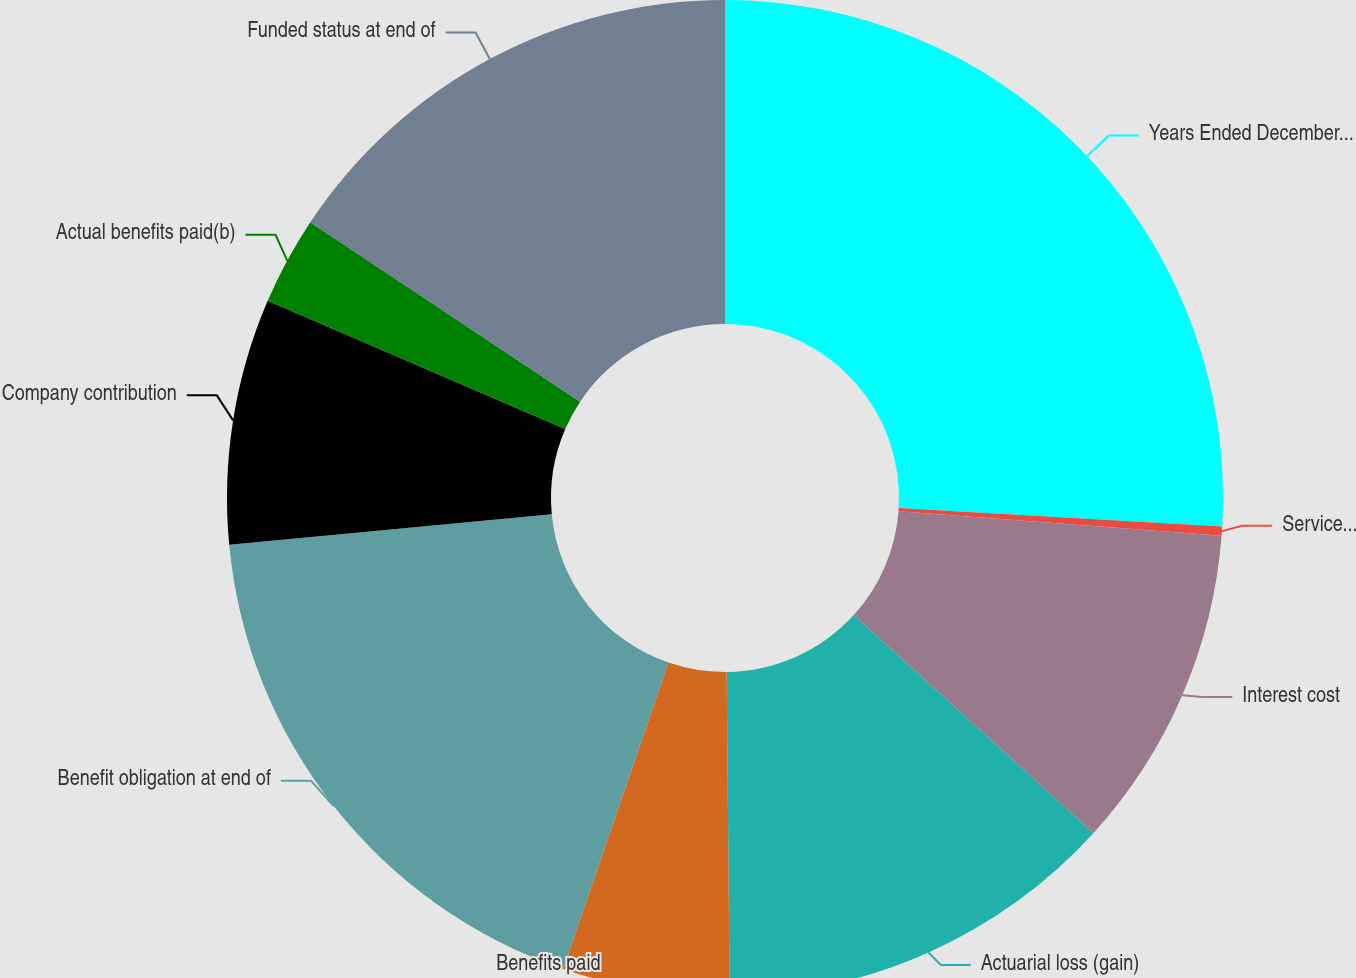<chart> <loc_0><loc_0><loc_500><loc_500><pie_chart><fcel>Years Ended December 31<fcel>Service cost<fcel>Interest cost<fcel>Actuarial loss (gain)<fcel>Benefits paid<fcel>Benefit obligation at end of<fcel>Company contribution<fcel>Actual benefits paid(b)<fcel>Funded status at end of<nl><fcel>25.91%<fcel>0.3%<fcel>10.54%<fcel>13.1%<fcel>5.42%<fcel>18.23%<fcel>7.98%<fcel>2.86%<fcel>15.66%<nl></chart> 